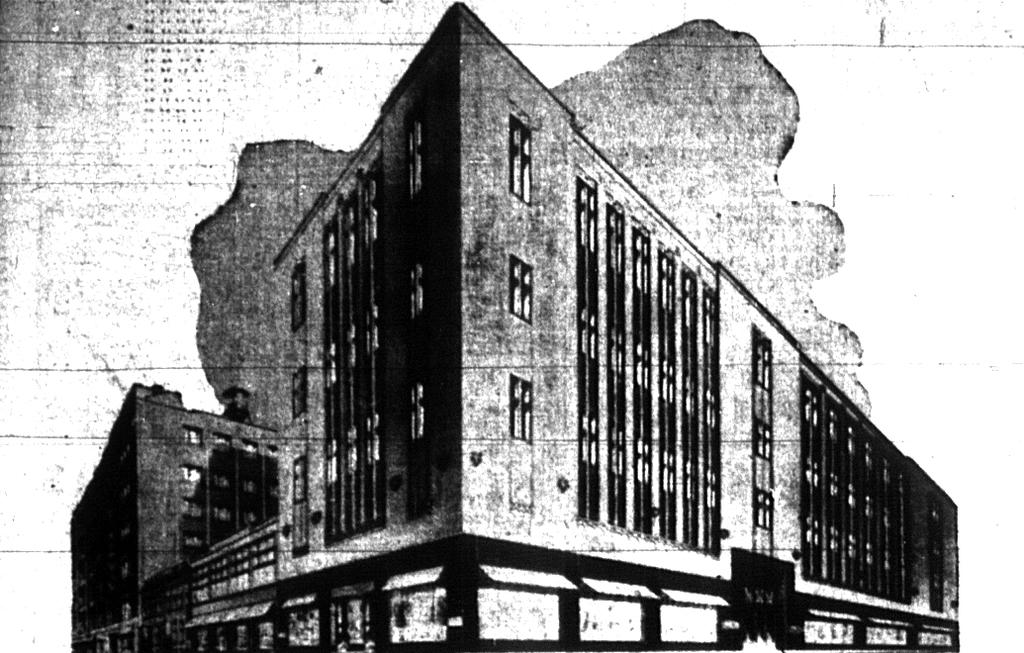What can be observed about the image? The image is edited. What type of structure is present in the image? There is a building in the image. What type of mitten is being worn by the building in the image? There is no mitten present in the image, as the main subject is a building. How many pages does the building have in the image? There are no pages associated with the building in the image, as it is a structure and not a book or document. 